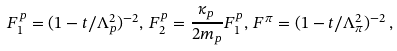Convert formula to latex. <formula><loc_0><loc_0><loc_500><loc_500>F _ { 1 } ^ { p } = ( 1 - t / \Lambda _ { p } ^ { 2 } ) ^ { - 2 } , \, F _ { 2 } ^ { p } = \frac { \kappa _ { p } } { 2 m _ { p } } F _ { 1 } ^ { p } , \, F ^ { \pi } = ( 1 - t / \Lambda _ { \pi } ^ { 2 } ) ^ { - 2 } \, ,</formula> 